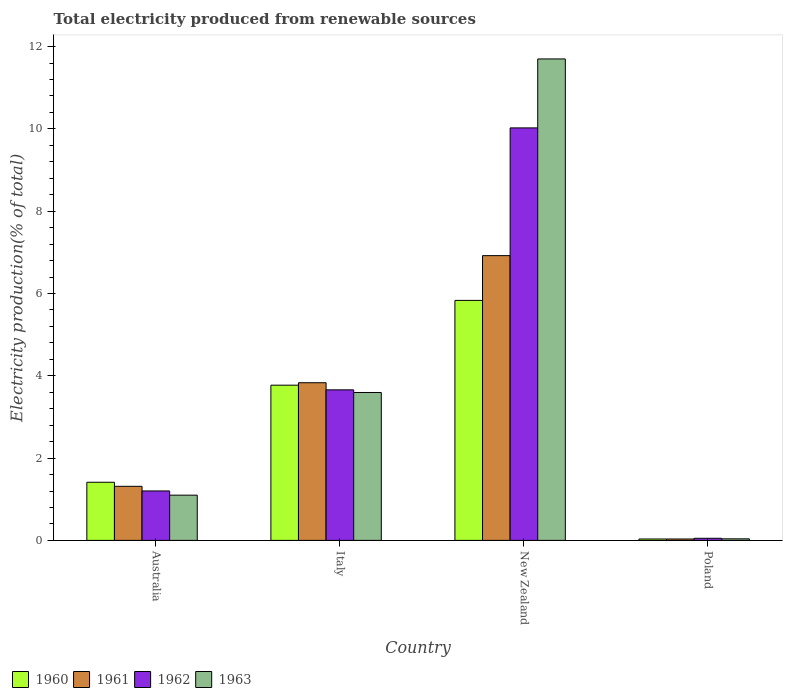How many different coloured bars are there?
Ensure brevity in your answer.  4. Are the number of bars on each tick of the X-axis equal?
Provide a short and direct response. Yes. What is the label of the 4th group of bars from the left?
Keep it short and to the point. Poland. What is the total electricity produced in 1962 in New Zealand?
Your answer should be very brief. 10.02. Across all countries, what is the maximum total electricity produced in 1960?
Provide a short and direct response. 5.83. Across all countries, what is the minimum total electricity produced in 1961?
Give a very brief answer. 0.03. In which country was the total electricity produced in 1963 maximum?
Offer a terse response. New Zealand. What is the total total electricity produced in 1963 in the graph?
Ensure brevity in your answer.  16.43. What is the difference between the total electricity produced in 1962 in Australia and that in Poland?
Your answer should be very brief. 1.15. What is the difference between the total electricity produced in 1963 in Australia and the total electricity produced in 1962 in Poland?
Your response must be concise. 1.05. What is the average total electricity produced in 1961 per country?
Make the answer very short. 3.02. What is the difference between the total electricity produced of/in 1960 and total electricity produced of/in 1963 in Australia?
Provide a short and direct response. 0.31. In how many countries, is the total electricity produced in 1961 greater than 4.8 %?
Your answer should be compact. 1. What is the ratio of the total electricity produced in 1963 in Italy to that in Poland?
Provide a succinct answer. 94.84. Is the difference between the total electricity produced in 1960 in Italy and Poland greater than the difference between the total electricity produced in 1963 in Italy and Poland?
Your response must be concise. Yes. What is the difference between the highest and the second highest total electricity produced in 1960?
Offer a very short reply. -2.36. What is the difference between the highest and the lowest total electricity produced in 1963?
Provide a succinct answer. 11.66. Is the sum of the total electricity produced in 1963 in Australia and Poland greater than the maximum total electricity produced in 1960 across all countries?
Keep it short and to the point. No. Is it the case that in every country, the sum of the total electricity produced in 1960 and total electricity produced in 1963 is greater than the sum of total electricity produced in 1961 and total electricity produced in 1962?
Offer a very short reply. No. What does the 2nd bar from the right in New Zealand represents?
Give a very brief answer. 1962. How many countries are there in the graph?
Your response must be concise. 4. Are the values on the major ticks of Y-axis written in scientific E-notation?
Offer a terse response. No. Does the graph contain any zero values?
Make the answer very short. No. Where does the legend appear in the graph?
Offer a very short reply. Bottom left. How many legend labels are there?
Your response must be concise. 4. How are the legend labels stacked?
Give a very brief answer. Horizontal. What is the title of the graph?
Give a very brief answer. Total electricity produced from renewable sources. What is the Electricity production(% of total) of 1960 in Australia?
Give a very brief answer. 1.41. What is the Electricity production(% of total) in 1961 in Australia?
Your answer should be compact. 1.31. What is the Electricity production(% of total) of 1962 in Australia?
Offer a terse response. 1.2. What is the Electricity production(% of total) of 1963 in Australia?
Give a very brief answer. 1.1. What is the Electricity production(% of total) of 1960 in Italy?
Make the answer very short. 3.77. What is the Electricity production(% of total) in 1961 in Italy?
Offer a very short reply. 3.83. What is the Electricity production(% of total) of 1962 in Italy?
Keep it short and to the point. 3.66. What is the Electricity production(% of total) in 1963 in Italy?
Give a very brief answer. 3.59. What is the Electricity production(% of total) of 1960 in New Zealand?
Offer a very short reply. 5.83. What is the Electricity production(% of total) of 1961 in New Zealand?
Keep it short and to the point. 6.92. What is the Electricity production(% of total) of 1962 in New Zealand?
Offer a terse response. 10.02. What is the Electricity production(% of total) of 1963 in New Zealand?
Keep it short and to the point. 11.7. What is the Electricity production(% of total) in 1960 in Poland?
Give a very brief answer. 0.03. What is the Electricity production(% of total) in 1961 in Poland?
Ensure brevity in your answer.  0.03. What is the Electricity production(% of total) of 1962 in Poland?
Make the answer very short. 0.05. What is the Electricity production(% of total) of 1963 in Poland?
Your response must be concise. 0.04. Across all countries, what is the maximum Electricity production(% of total) in 1960?
Offer a terse response. 5.83. Across all countries, what is the maximum Electricity production(% of total) of 1961?
Ensure brevity in your answer.  6.92. Across all countries, what is the maximum Electricity production(% of total) of 1962?
Offer a very short reply. 10.02. Across all countries, what is the maximum Electricity production(% of total) in 1963?
Your answer should be compact. 11.7. Across all countries, what is the minimum Electricity production(% of total) of 1960?
Provide a succinct answer. 0.03. Across all countries, what is the minimum Electricity production(% of total) of 1961?
Your answer should be compact. 0.03. Across all countries, what is the minimum Electricity production(% of total) of 1962?
Ensure brevity in your answer.  0.05. Across all countries, what is the minimum Electricity production(% of total) of 1963?
Provide a succinct answer. 0.04. What is the total Electricity production(% of total) in 1960 in the graph?
Make the answer very short. 11.05. What is the total Electricity production(% of total) of 1962 in the graph?
Provide a short and direct response. 14.94. What is the total Electricity production(% of total) in 1963 in the graph?
Offer a terse response. 16.43. What is the difference between the Electricity production(% of total) of 1960 in Australia and that in Italy?
Give a very brief answer. -2.36. What is the difference between the Electricity production(% of total) of 1961 in Australia and that in Italy?
Offer a terse response. -2.52. What is the difference between the Electricity production(% of total) in 1962 in Australia and that in Italy?
Offer a terse response. -2.46. What is the difference between the Electricity production(% of total) in 1963 in Australia and that in Italy?
Your response must be concise. -2.5. What is the difference between the Electricity production(% of total) of 1960 in Australia and that in New Zealand?
Provide a succinct answer. -4.42. What is the difference between the Electricity production(% of total) in 1961 in Australia and that in New Zealand?
Your response must be concise. -5.61. What is the difference between the Electricity production(% of total) of 1962 in Australia and that in New Zealand?
Offer a very short reply. -8.82. What is the difference between the Electricity production(% of total) in 1963 in Australia and that in New Zealand?
Offer a very short reply. -10.6. What is the difference between the Electricity production(% of total) in 1960 in Australia and that in Poland?
Give a very brief answer. 1.38. What is the difference between the Electricity production(% of total) of 1961 in Australia and that in Poland?
Offer a very short reply. 1.28. What is the difference between the Electricity production(% of total) of 1962 in Australia and that in Poland?
Keep it short and to the point. 1.15. What is the difference between the Electricity production(% of total) in 1963 in Australia and that in Poland?
Give a very brief answer. 1.06. What is the difference between the Electricity production(% of total) of 1960 in Italy and that in New Zealand?
Make the answer very short. -2.06. What is the difference between the Electricity production(% of total) in 1961 in Italy and that in New Zealand?
Provide a succinct answer. -3.09. What is the difference between the Electricity production(% of total) in 1962 in Italy and that in New Zealand?
Offer a very short reply. -6.37. What is the difference between the Electricity production(% of total) in 1963 in Italy and that in New Zealand?
Provide a succinct answer. -8.11. What is the difference between the Electricity production(% of total) of 1960 in Italy and that in Poland?
Provide a short and direct response. 3.74. What is the difference between the Electricity production(% of total) of 1961 in Italy and that in Poland?
Provide a short and direct response. 3.8. What is the difference between the Electricity production(% of total) in 1962 in Italy and that in Poland?
Provide a succinct answer. 3.61. What is the difference between the Electricity production(% of total) of 1963 in Italy and that in Poland?
Offer a terse response. 3.56. What is the difference between the Electricity production(% of total) in 1960 in New Zealand and that in Poland?
Offer a terse response. 5.8. What is the difference between the Electricity production(% of total) in 1961 in New Zealand and that in Poland?
Offer a terse response. 6.89. What is the difference between the Electricity production(% of total) in 1962 in New Zealand and that in Poland?
Your answer should be compact. 9.97. What is the difference between the Electricity production(% of total) in 1963 in New Zealand and that in Poland?
Keep it short and to the point. 11.66. What is the difference between the Electricity production(% of total) in 1960 in Australia and the Electricity production(% of total) in 1961 in Italy?
Make the answer very short. -2.42. What is the difference between the Electricity production(% of total) of 1960 in Australia and the Electricity production(% of total) of 1962 in Italy?
Make the answer very short. -2.25. What is the difference between the Electricity production(% of total) of 1960 in Australia and the Electricity production(% of total) of 1963 in Italy?
Your response must be concise. -2.18. What is the difference between the Electricity production(% of total) of 1961 in Australia and the Electricity production(% of total) of 1962 in Italy?
Keep it short and to the point. -2.34. What is the difference between the Electricity production(% of total) of 1961 in Australia and the Electricity production(% of total) of 1963 in Italy?
Provide a succinct answer. -2.28. What is the difference between the Electricity production(% of total) in 1962 in Australia and the Electricity production(% of total) in 1963 in Italy?
Make the answer very short. -2.39. What is the difference between the Electricity production(% of total) in 1960 in Australia and the Electricity production(% of total) in 1961 in New Zealand?
Your answer should be compact. -5.51. What is the difference between the Electricity production(% of total) in 1960 in Australia and the Electricity production(% of total) in 1962 in New Zealand?
Provide a short and direct response. -8.61. What is the difference between the Electricity production(% of total) of 1960 in Australia and the Electricity production(% of total) of 1963 in New Zealand?
Provide a short and direct response. -10.29. What is the difference between the Electricity production(% of total) in 1961 in Australia and the Electricity production(% of total) in 1962 in New Zealand?
Give a very brief answer. -8.71. What is the difference between the Electricity production(% of total) in 1961 in Australia and the Electricity production(% of total) in 1963 in New Zealand?
Give a very brief answer. -10.39. What is the difference between the Electricity production(% of total) of 1962 in Australia and the Electricity production(% of total) of 1963 in New Zealand?
Offer a terse response. -10.5. What is the difference between the Electricity production(% of total) in 1960 in Australia and the Electricity production(% of total) in 1961 in Poland?
Offer a terse response. 1.38. What is the difference between the Electricity production(% of total) in 1960 in Australia and the Electricity production(% of total) in 1962 in Poland?
Ensure brevity in your answer.  1.36. What is the difference between the Electricity production(% of total) of 1960 in Australia and the Electricity production(% of total) of 1963 in Poland?
Ensure brevity in your answer.  1.37. What is the difference between the Electricity production(% of total) of 1961 in Australia and the Electricity production(% of total) of 1962 in Poland?
Make the answer very short. 1.26. What is the difference between the Electricity production(% of total) of 1961 in Australia and the Electricity production(% of total) of 1963 in Poland?
Keep it short and to the point. 1.28. What is the difference between the Electricity production(% of total) in 1962 in Australia and the Electricity production(% of total) in 1963 in Poland?
Offer a terse response. 1.16. What is the difference between the Electricity production(% of total) in 1960 in Italy and the Electricity production(% of total) in 1961 in New Zealand?
Offer a terse response. -3.15. What is the difference between the Electricity production(% of total) in 1960 in Italy and the Electricity production(% of total) in 1962 in New Zealand?
Your answer should be compact. -6.25. What is the difference between the Electricity production(% of total) in 1960 in Italy and the Electricity production(% of total) in 1963 in New Zealand?
Give a very brief answer. -7.93. What is the difference between the Electricity production(% of total) of 1961 in Italy and the Electricity production(% of total) of 1962 in New Zealand?
Your answer should be very brief. -6.19. What is the difference between the Electricity production(% of total) in 1961 in Italy and the Electricity production(% of total) in 1963 in New Zealand?
Provide a short and direct response. -7.87. What is the difference between the Electricity production(% of total) in 1962 in Italy and the Electricity production(% of total) in 1963 in New Zealand?
Provide a succinct answer. -8.04. What is the difference between the Electricity production(% of total) in 1960 in Italy and the Electricity production(% of total) in 1961 in Poland?
Your response must be concise. 3.74. What is the difference between the Electricity production(% of total) in 1960 in Italy and the Electricity production(% of total) in 1962 in Poland?
Offer a very short reply. 3.72. What is the difference between the Electricity production(% of total) in 1960 in Italy and the Electricity production(% of total) in 1963 in Poland?
Keep it short and to the point. 3.73. What is the difference between the Electricity production(% of total) in 1961 in Italy and the Electricity production(% of total) in 1962 in Poland?
Offer a terse response. 3.78. What is the difference between the Electricity production(% of total) of 1961 in Italy and the Electricity production(% of total) of 1963 in Poland?
Your response must be concise. 3.79. What is the difference between the Electricity production(% of total) of 1962 in Italy and the Electricity production(% of total) of 1963 in Poland?
Your answer should be compact. 3.62. What is the difference between the Electricity production(% of total) in 1960 in New Zealand and the Electricity production(% of total) in 1961 in Poland?
Give a very brief answer. 5.8. What is the difference between the Electricity production(% of total) of 1960 in New Zealand and the Electricity production(% of total) of 1962 in Poland?
Make the answer very short. 5.78. What is the difference between the Electricity production(% of total) in 1960 in New Zealand and the Electricity production(% of total) in 1963 in Poland?
Offer a terse response. 5.79. What is the difference between the Electricity production(% of total) in 1961 in New Zealand and the Electricity production(% of total) in 1962 in Poland?
Your response must be concise. 6.87. What is the difference between the Electricity production(% of total) of 1961 in New Zealand and the Electricity production(% of total) of 1963 in Poland?
Ensure brevity in your answer.  6.88. What is the difference between the Electricity production(% of total) in 1962 in New Zealand and the Electricity production(% of total) in 1963 in Poland?
Your answer should be very brief. 9.99. What is the average Electricity production(% of total) of 1960 per country?
Your response must be concise. 2.76. What is the average Electricity production(% of total) in 1961 per country?
Keep it short and to the point. 3.02. What is the average Electricity production(% of total) of 1962 per country?
Your response must be concise. 3.73. What is the average Electricity production(% of total) of 1963 per country?
Give a very brief answer. 4.11. What is the difference between the Electricity production(% of total) in 1960 and Electricity production(% of total) in 1961 in Australia?
Your answer should be compact. 0.1. What is the difference between the Electricity production(% of total) of 1960 and Electricity production(% of total) of 1962 in Australia?
Your response must be concise. 0.21. What is the difference between the Electricity production(% of total) of 1960 and Electricity production(% of total) of 1963 in Australia?
Ensure brevity in your answer.  0.31. What is the difference between the Electricity production(% of total) of 1961 and Electricity production(% of total) of 1962 in Australia?
Offer a terse response. 0.11. What is the difference between the Electricity production(% of total) in 1961 and Electricity production(% of total) in 1963 in Australia?
Ensure brevity in your answer.  0.21. What is the difference between the Electricity production(% of total) of 1962 and Electricity production(% of total) of 1963 in Australia?
Ensure brevity in your answer.  0.1. What is the difference between the Electricity production(% of total) in 1960 and Electricity production(% of total) in 1961 in Italy?
Keep it short and to the point. -0.06. What is the difference between the Electricity production(% of total) of 1960 and Electricity production(% of total) of 1962 in Italy?
Your answer should be compact. 0.11. What is the difference between the Electricity production(% of total) of 1960 and Electricity production(% of total) of 1963 in Italy?
Your response must be concise. 0.18. What is the difference between the Electricity production(% of total) of 1961 and Electricity production(% of total) of 1962 in Italy?
Provide a short and direct response. 0.17. What is the difference between the Electricity production(% of total) in 1961 and Electricity production(% of total) in 1963 in Italy?
Make the answer very short. 0.24. What is the difference between the Electricity production(% of total) of 1962 and Electricity production(% of total) of 1963 in Italy?
Offer a very short reply. 0.06. What is the difference between the Electricity production(% of total) in 1960 and Electricity production(% of total) in 1961 in New Zealand?
Your answer should be very brief. -1.09. What is the difference between the Electricity production(% of total) in 1960 and Electricity production(% of total) in 1962 in New Zealand?
Offer a very short reply. -4.19. What is the difference between the Electricity production(% of total) of 1960 and Electricity production(% of total) of 1963 in New Zealand?
Your answer should be compact. -5.87. What is the difference between the Electricity production(% of total) of 1961 and Electricity production(% of total) of 1962 in New Zealand?
Provide a short and direct response. -3.1. What is the difference between the Electricity production(% of total) of 1961 and Electricity production(% of total) of 1963 in New Zealand?
Keep it short and to the point. -4.78. What is the difference between the Electricity production(% of total) in 1962 and Electricity production(% of total) in 1963 in New Zealand?
Your answer should be very brief. -1.68. What is the difference between the Electricity production(% of total) in 1960 and Electricity production(% of total) in 1961 in Poland?
Provide a short and direct response. 0. What is the difference between the Electricity production(% of total) in 1960 and Electricity production(% of total) in 1962 in Poland?
Make the answer very short. -0.02. What is the difference between the Electricity production(% of total) of 1960 and Electricity production(% of total) of 1963 in Poland?
Ensure brevity in your answer.  -0. What is the difference between the Electricity production(% of total) in 1961 and Electricity production(% of total) in 1962 in Poland?
Your answer should be very brief. -0.02. What is the difference between the Electricity production(% of total) of 1961 and Electricity production(% of total) of 1963 in Poland?
Offer a very short reply. -0. What is the difference between the Electricity production(% of total) in 1962 and Electricity production(% of total) in 1963 in Poland?
Provide a succinct answer. 0.01. What is the ratio of the Electricity production(% of total) in 1960 in Australia to that in Italy?
Your answer should be compact. 0.37. What is the ratio of the Electricity production(% of total) of 1961 in Australia to that in Italy?
Your response must be concise. 0.34. What is the ratio of the Electricity production(% of total) of 1962 in Australia to that in Italy?
Your response must be concise. 0.33. What is the ratio of the Electricity production(% of total) of 1963 in Australia to that in Italy?
Your answer should be compact. 0.31. What is the ratio of the Electricity production(% of total) of 1960 in Australia to that in New Zealand?
Offer a very short reply. 0.24. What is the ratio of the Electricity production(% of total) of 1961 in Australia to that in New Zealand?
Offer a terse response. 0.19. What is the ratio of the Electricity production(% of total) of 1962 in Australia to that in New Zealand?
Keep it short and to the point. 0.12. What is the ratio of the Electricity production(% of total) of 1963 in Australia to that in New Zealand?
Keep it short and to the point. 0.09. What is the ratio of the Electricity production(% of total) of 1960 in Australia to that in Poland?
Make the answer very short. 41.37. What is the ratio of the Electricity production(% of total) in 1961 in Australia to that in Poland?
Your answer should be very brief. 38.51. What is the ratio of the Electricity production(% of total) in 1962 in Australia to that in Poland?
Your answer should be very brief. 23.61. What is the ratio of the Electricity production(% of total) in 1963 in Australia to that in Poland?
Provide a short and direct response. 29. What is the ratio of the Electricity production(% of total) of 1960 in Italy to that in New Zealand?
Make the answer very short. 0.65. What is the ratio of the Electricity production(% of total) in 1961 in Italy to that in New Zealand?
Offer a terse response. 0.55. What is the ratio of the Electricity production(% of total) in 1962 in Italy to that in New Zealand?
Give a very brief answer. 0.36. What is the ratio of the Electricity production(% of total) of 1963 in Italy to that in New Zealand?
Give a very brief answer. 0.31. What is the ratio of the Electricity production(% of total) in 1960 in Italy to that in Poland?
Your response must be concise. 110.45. What is the ratio of the Electricity production(% of total) of 1961 in Italy to that in Poland?
Keep it short and to the point. 112.3. What is the ratio of the Electricity production(% of total) of 1962 in Italy to that in Poland?
Offer a terse response. 71.88. What is the ratio of the Electricity production(% of total) in 1963 in Italy to that in Poland?
Give a very brief answer. 94.84. What is the ratio of the Electricity production(% of total) in 1960 in New Zealand to that in Poland?
Offer a very short reply. 170.79. What is the ratio of the Electricity production(% of total) in 1961 in New Zealand to that in Poland?
Offer a very short reply. 202.83. What is the ratio of the Electricity production(% of total) in 1962 in New Zealand to that in Poland?
Offer a very short reply. 196.95. What is the ratio of the Electricity production(% of total) of 1963 in New Zealand to that in Poland?
Make the answer very short. 308.73. What is the difference between the highest and the second highest Electricity production(% of total) in 1960?
Your response must be concise. 2.06. What is the difference between the highest and the second highest Electricity production(% of total) in 1961?
Offer a terse response. 3.09. What is the difference between the highest and the second highest Electricity production(% of total) of 1962?
Offer a terse response. 6.37. What is the difference between the highest and the second highest Electricity production(% of total) in 1963?
Your response must be concise. 8.11. What is the difference between the highest and the lowest Electricity production(% of total) in 1960?
Provide a succinct answer. 5.8. What is the difference between the highest and the lowest Electricity production(% of total) of 1961?
Make the answer very short. 6.89. What is the difference between the highest and the lowest Electricity production(% of total) in 1962?
Provide a short and direct response. 9.97. What is the difference between the highest and the lowest Electricity production(% of total) in 1963?
Offer a very short reply. 11.66. 